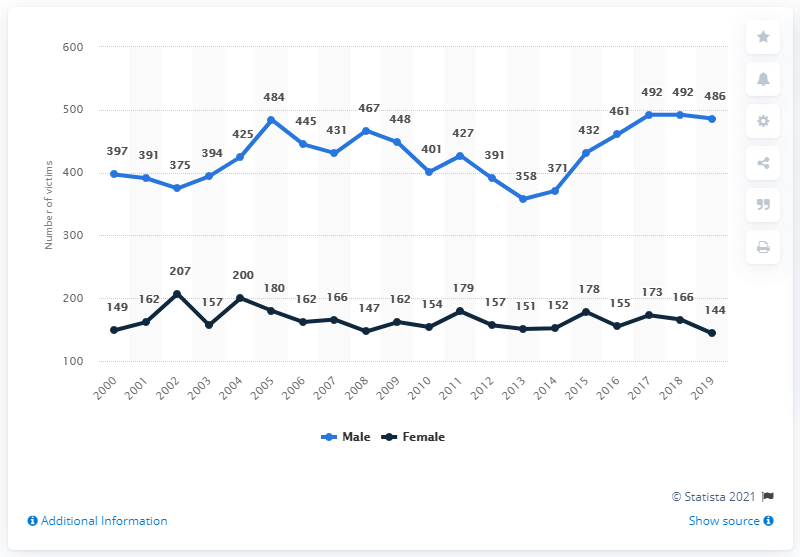List a handful of essential elements in this visual. In 2019, there were 486 male and 144 female homicide victims in Canada. There were 144 female homicide victims in Canada in 2019. 